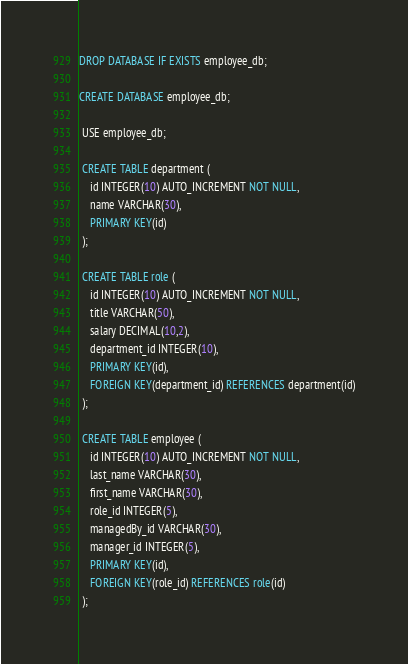<code> <loc_0><loc_0><loc_500><loc_500><_SQL_>DROP DATABASE IF EXISTS employee_db;

CREATE DATABASE employee_db;
 
 USE employee_db;

 CREATE TABLE department (
    id INTEGER(10) AUTO_INCREMENT NOT NULL,
    name VARCHAR(30),
    PRIMARY KEY(id)
 );

 CREATE TABLE role (
 	id INTEGER(10) AUTO_INCREMENT NOT NULL,
    title VARCHAR(50),
    salary DECIMAL(10,2),
    department_id INTEGER(10),
    PRIMARY KEY(id),
    FOREIGN KEY(department_id) REFERENCES department(id)
 );
 
 CREATE TABLE employee (
    id INTEGER(10) AUTO_INCREMENT NOT NULL,
    last_name VARCHAR(30),
    first_name VARCHAR(30),
    role_id INTEGER(5),
    managedBy_id VARCHAR(30),
    manager_id INTEGER(5),
    PRIMARY KEY(id),
    FOREIGN KEY(role_id) REFERENCES role(id)
 );</code> 